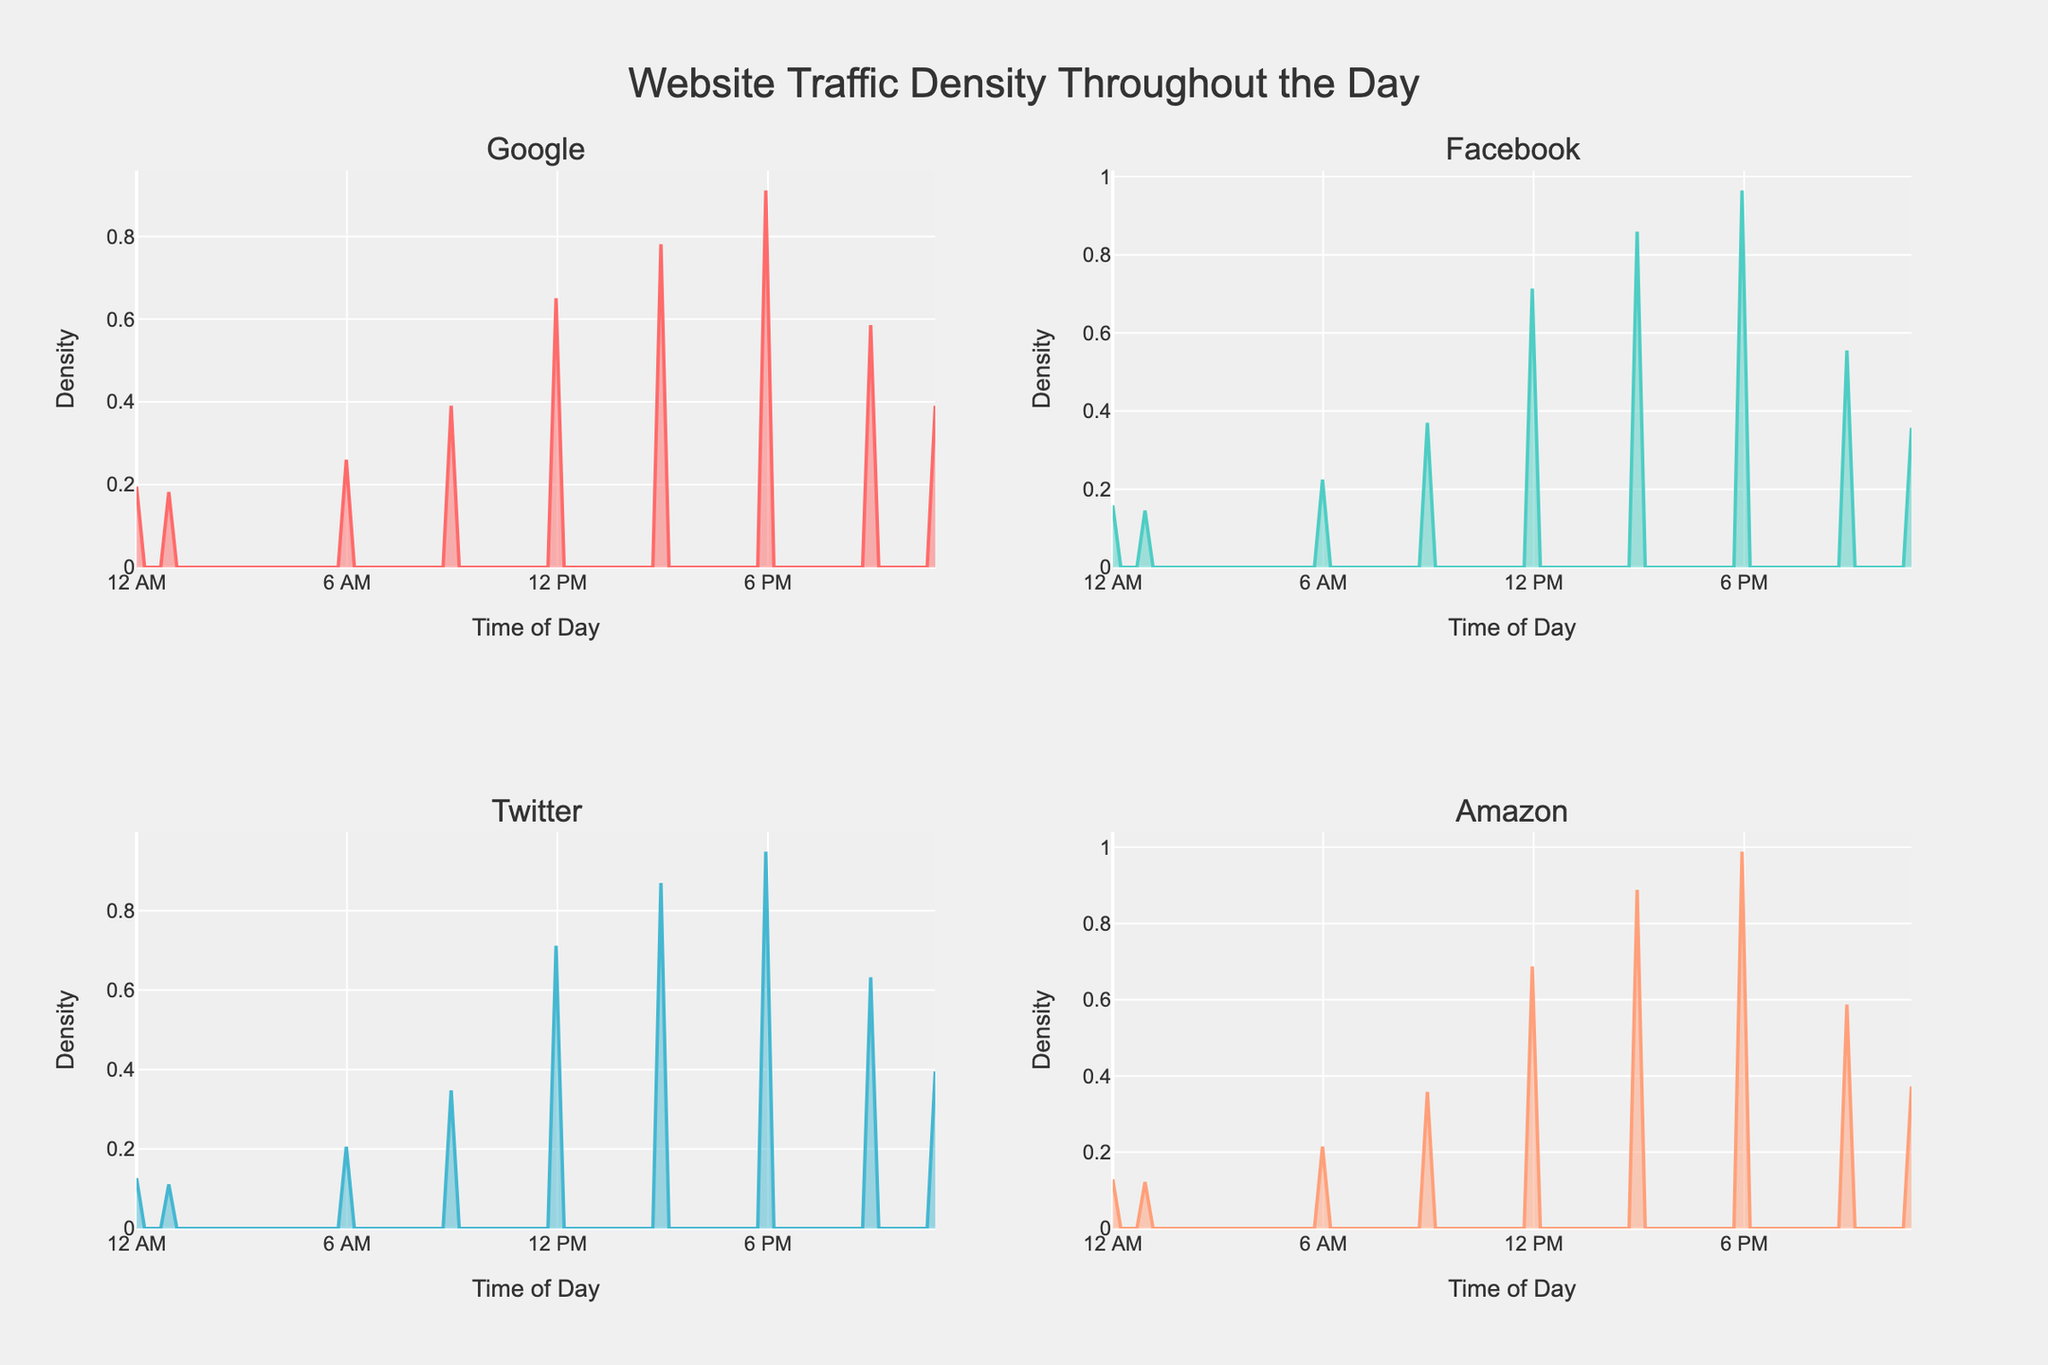How many websites are depicted in the figure? The four subplot titles denote each website. These titles represent the different websites being analyzed in the figure. Hence, you can count the titles to determine the number of websites.
Answer: Four Which website has the highest peak density? To determine the highest peak density, look at the highest point on the density curve in each subplot. The website subplot with the most elevated peak indicates the website with the highest density.
Answer: Facebook What time of day does Amazon have the highest density of visitors? Examine the subplot for Amazon. Identify the peak of the density curve and note the corresponding time on the x-axis. This indicates when Amazon experiences its highest visitor density.
Answer: 6 PM Compare the visitor density patterns between Google and Twitter in the early morning (12 AM to 6 AM). Focus on the density curves for Google and Twitter in their respective subplots. Evaluate the areas under the curves between 12 AM and 6 AM, noting which website has higher density values during this period.
Answer: Google has higher density What is the common peak time for website traffic across all websites? Observe each subplot for its peak density time. If multiple subplots show peaks around the same time, this indicates a common peak time for traffic across all websites.
Answer: 6 PM During which time period does Twitter have a significant dip in visitor density? Assess the density curve for Twitter. Identify where the curve shows a noticeable decline or dip, and note the corresponding time period on the x-axis.
Answer: 3 AM How does Facebook's visitor density at noon compare to its density at midnight? Look at the density curve for Facebook at noon (12 PM) and at midnight (12 AM). Compare the curve heights at these times to determine whether visitor density is higher at noon or midnight.
Answer: Higher at noon What color represents the density plot for Google? Each density plot is assigned a specific color. By identifying and noting the color used for Google's subplot, you determine the representation.
Answer: Light blue Are there any times of day when Amazon and Facebook have very low visitor density? Examine the density curves for Amazon and Facebook. Look for time periods where both curves are at or near their lowest points.
Answer: Midnight and 3 AM 